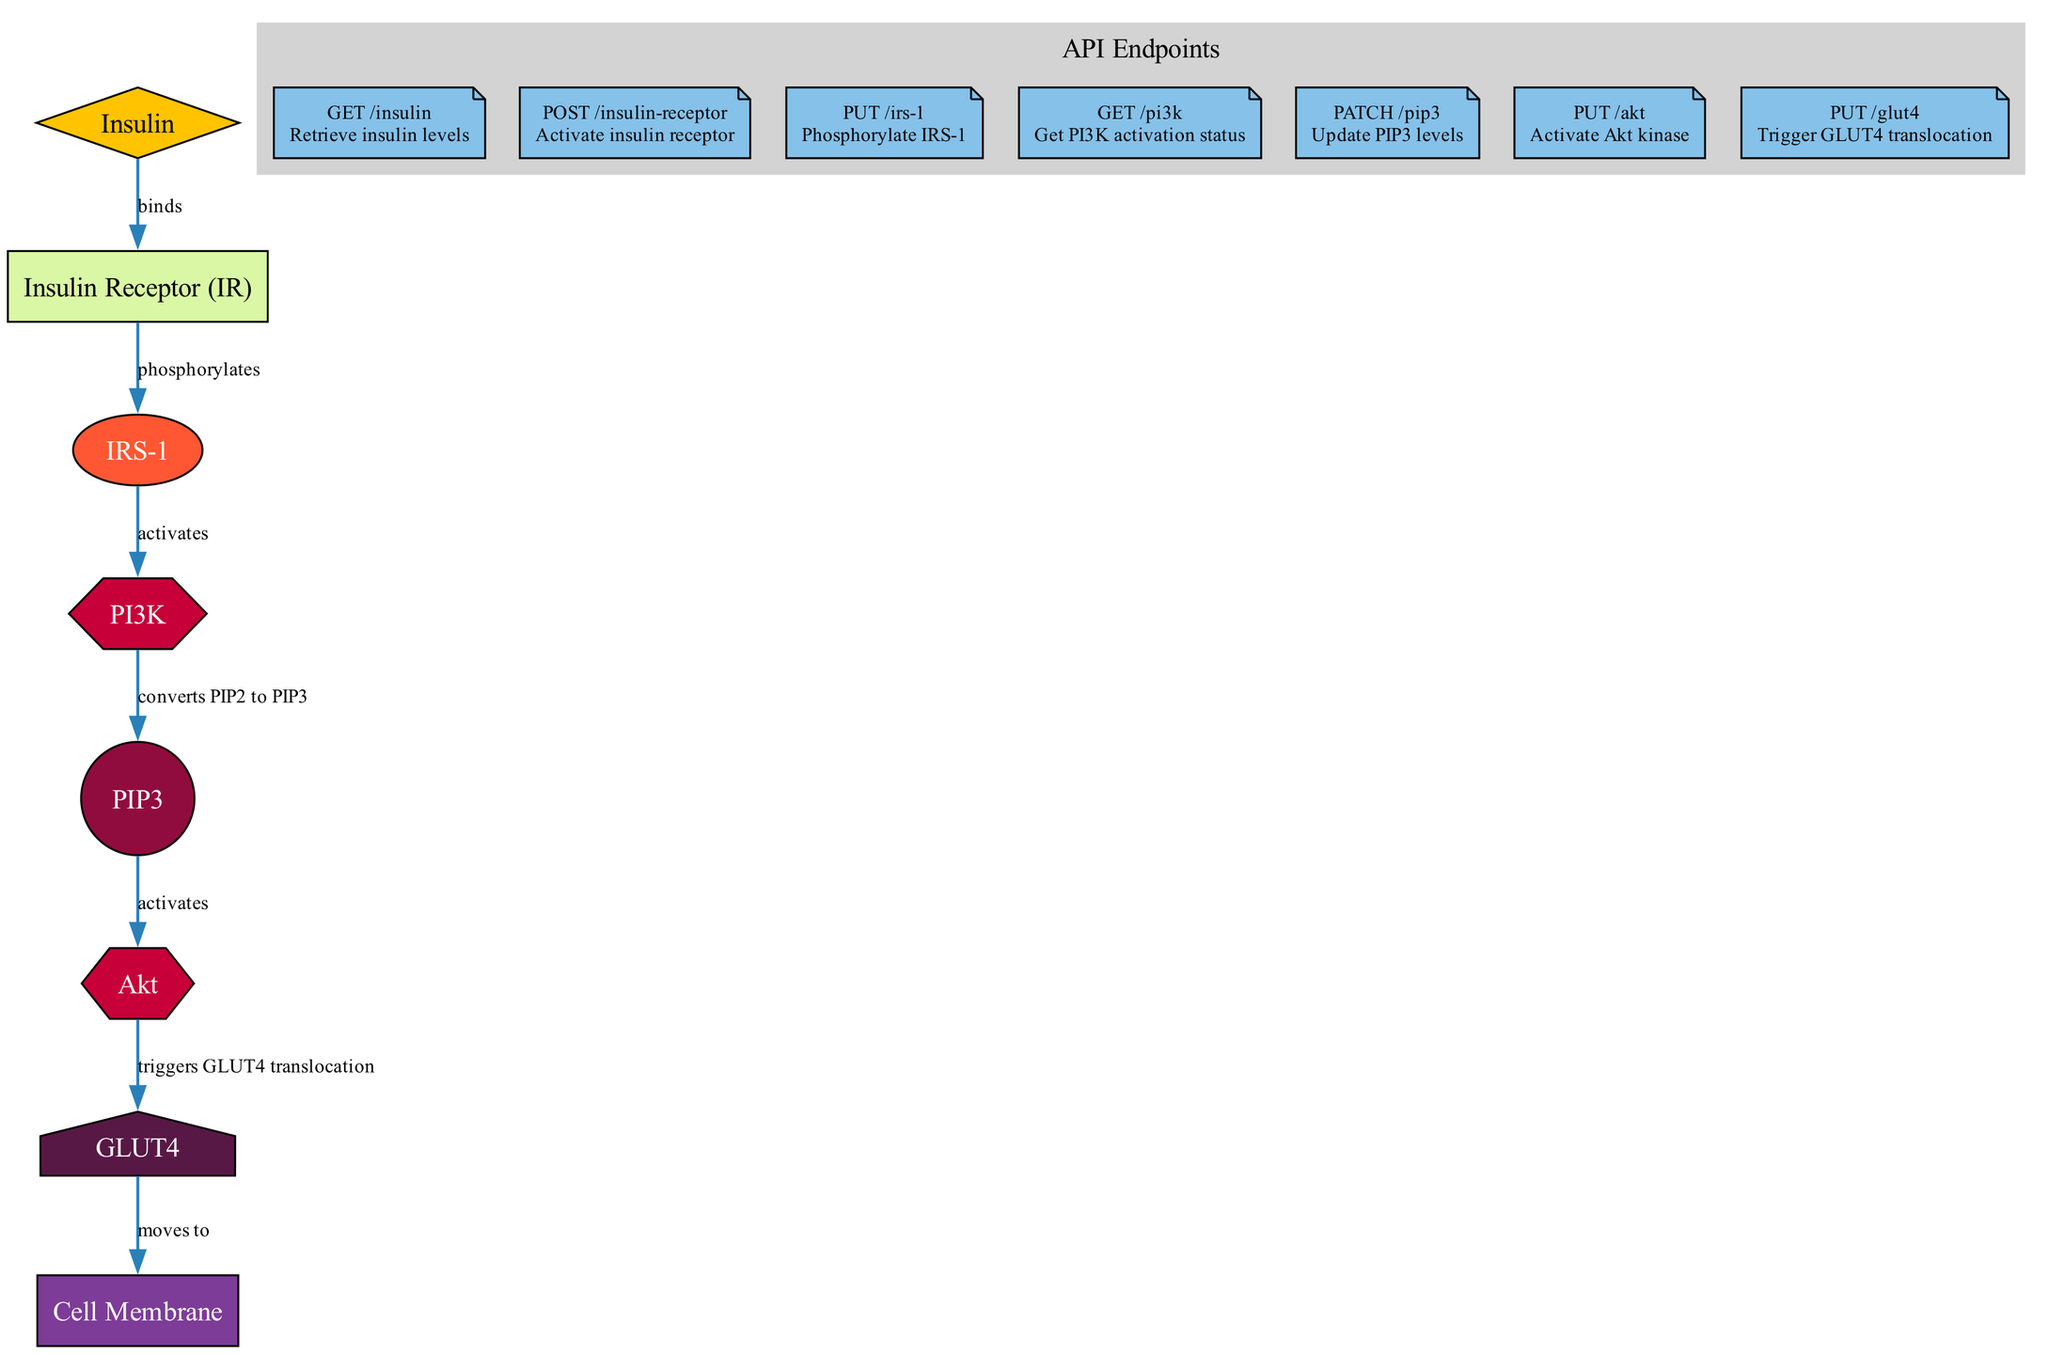What is the hormone indicated at the start of the pathway? The initial node in the diagram is labeled "Insulin", which is classified as a hormone.
Answer: Insulin How many key proteins are involved in the insulin signaling pathway? Counting the nodes that represent proteins (Insulin Receptor, IRS-1, PI3K, Akt, GLUT4) reveals that there are five key proteins depicted in the diagram.
Answer: 5 What is the role of IRS-1 in the pathway? The edge connecting Insulin Receptor (IR) to IRS-1 indicates that IRS-1 is phosphorylated by the Insulin Receptor, establishing its role as an adaptor protein activated by this phosphorylation.
Answer: Phosphorylated What does PIP3 activate? The edge from PIP3 to Akt shows that PIP3 activates Akt in the signaling pathway, illustrating the relationship between these two components.
Answer: Akt Which protein moves to the cell membrane? The diagram indicates that GLUT4 moves to the Cell Membrane, based on the directed edge connecting these two nodes.
Answer: GLUT4 How does PI3K interact with PIP2? The diagram shows that PI3K converts PIP2 to PIP3, detailing the specific biochemical action provided in this edge.
Answer: Converts What triggers GLUT4 translocation? The edge from Akt to GLUT4 specifies that Akt triggers the translocation of GLUT4, linking the activation of Akt directly to GLUT4's movement.
Answer: Akt Which type of node is Insulin Receptor? Reviewing the node characteristics, Insulin Receptor is categorized as a "Receptor," as indicated by its type label.
Answer: Receptor What is the API endpoint to retrieve insulin levels? The specific API endpoint labeled "GET /insulin" is dedicated to retrieving insulin levels, as noted in the diagram's API section.
Answer: GET /insulin How many edges are present in the diagram? Counting the connections (edges) between nodes (Insulin to IR, IR to IRS-1, IRS-1 to PI3K, PI3K to PIP3, PIP3 to Akt, Akt to GLUT4, GLUT4 to Cell Membrane) shows a total of seven edges.
Answer: 7 